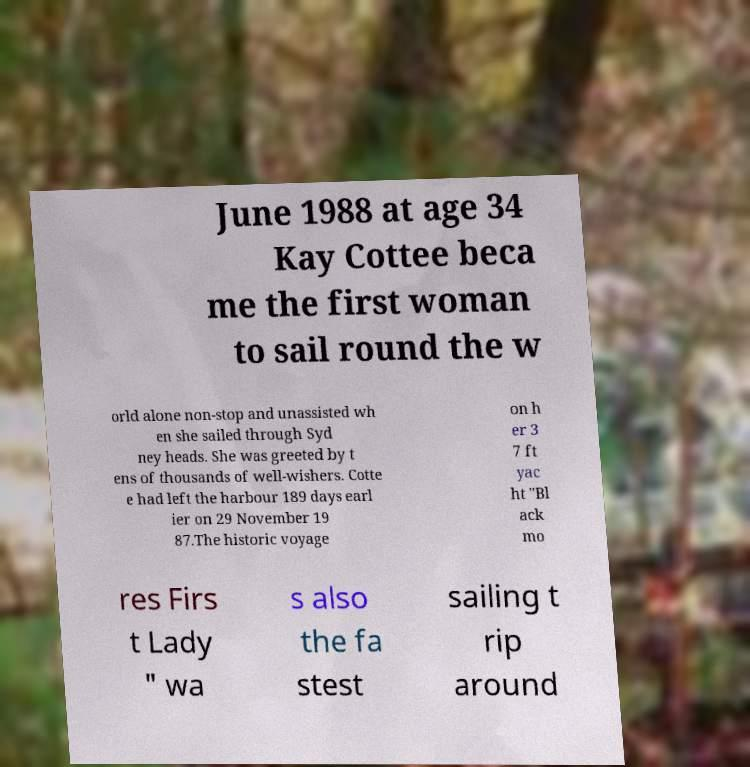Could you assist in decoding the text presented in this image and type it out clearly? June 1988 at age 34 Kay Cottee beca me the first woman to sail round the w orld alone non-stop and unassisted wh en she sailed through Syd ney heads. She was greeted by t ens of thousands of well-wishers. Cotte e had left the harbour 189 days earl ier on 29 November 19 87.The historic voyage on h er 3 7 ft yac ht "Bl ack mo res Firs t Lady " wa s also the fa stest sailing t rip around 